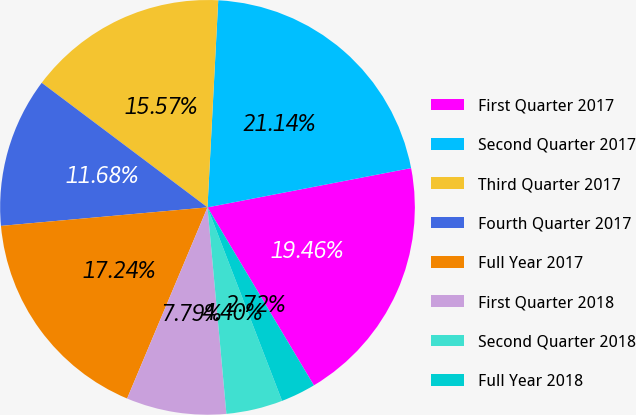Convert chart. <chart><loc_0><loc_0><loc_500><loc_500><pie_chart><fcel>First Quarter 2017<fcel>Second Quarter 2017<fcel>Third Quarter 2017<fcel>Fourth Quarter 2017<fcel>Full Year 2017<fcel>First Quarter 2018<fcel>Second Quarter 2018<fcel>Full Year 2018<nl><fcel>19.46%<fcel>21.14%<fcel>15.57%<fcel>11.68%<fcel>17.24%<fcel>7.79%<fcel>4.4%<fcel>2.72%<nl></chart> 